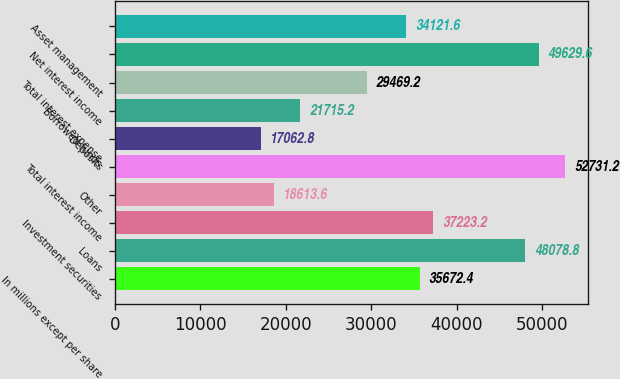<chart> <loc_0><loc_0><loc_500><loc_500><bar_chart><fcel>In millions except per share<fcel>Loans<fcel>Investment securities<fcel>Other<fcel>Total interest income<fcel>Deposits<fcel>Borrowed funds<fcel>Total interest expense<fcel>Net interest income<fcel>Asset management<nl><fcel>35672.4<fcel>48078.8<fcel>37223.2<fcel>18613.6<fcel>52731.2<fcel>17062.8<fcel>21715.2<fcel>29469.2<fcel>49629.6<fcel>34121.6<nl></chart> 